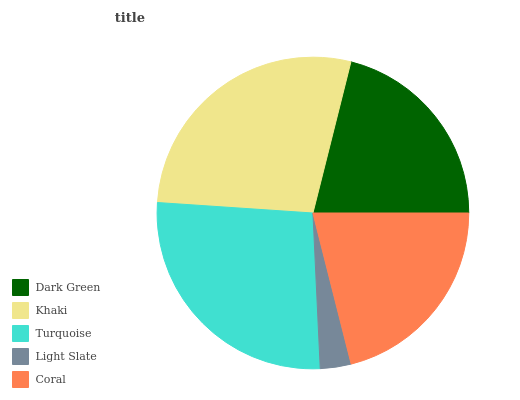Is Light Slate the minimum?
Answer yes or no. Yes. Is Khaki the maximum?
Answer yes or no. Yes. Is Turquoise the minimum?
Answer yes or no. No. Is Turquoise the maximum?
Answer yes or no. No. Is Khaki greater than Turquoise?
Answer yes or no. Yes. Is Turquoise less than Khaki?
Answer yes or no. Yes. Is Turquoise greater than Khaki?
Answer yes or no. No. Is Khaki less than Turquoise?
Answer yes or no. No. Is Dark Green the high median?
Answer yes or no. Yes. Is Dark Green the low median?
Answer yes or no. Yes. Is Turquoise the high median?
Answer yes or no. No. Is Coral the low median?
Answer yes or no. No. 